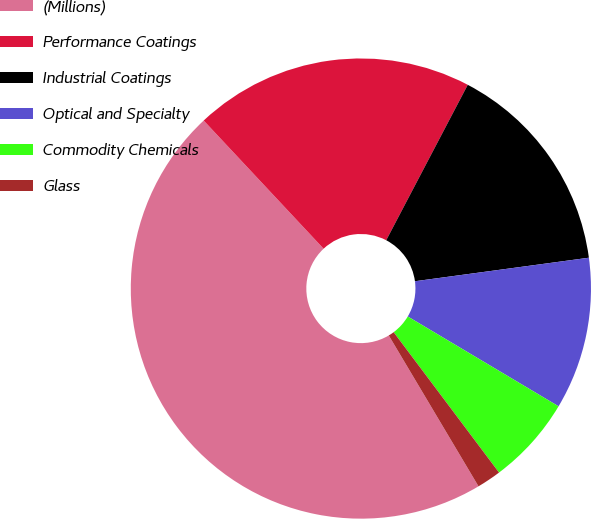Convert chart to OTSL. <chart><loc_0><loc_0><loc_500><loc_500><pie_chart><fcel>(Millions)<fcel>Performance Coatings<fcel>Industrial Coatings<fcel>Optical and Specialty<fcel>Commodity Chemicals<fcel>Glass<nl><fcel>46.57%<fcel>19.66%<fcel>15.17%<fcel>10.69%<fcel>6.2%<fcel>1.71%<nl></chart> 